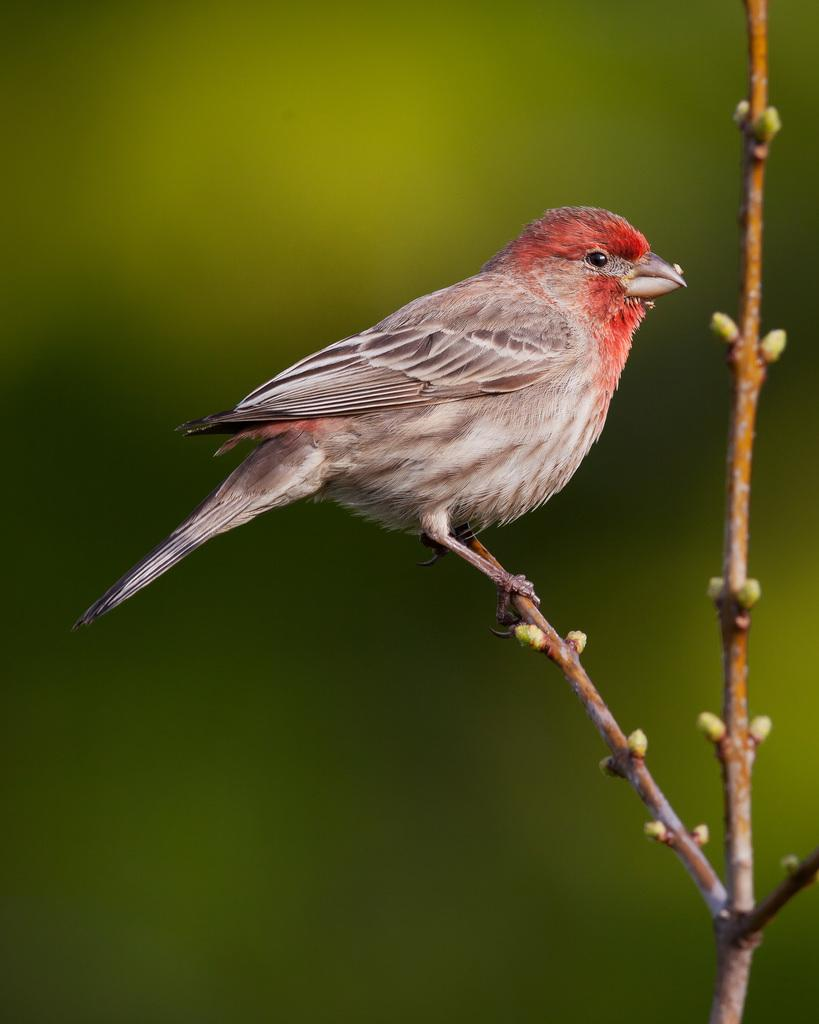What type of animal is in the image? There is a bird in the image. Where is the bird located? The bird is on a branch. Can you describe the background of the image? The background of the image is blurry. What type of building can be seen in the background of the image? There is no building present in the image; it features a bird on a branch with a blurry background. How many bats are visible in the image? There are no bats present in the image; it features a bird on a branch with a blurry background. 